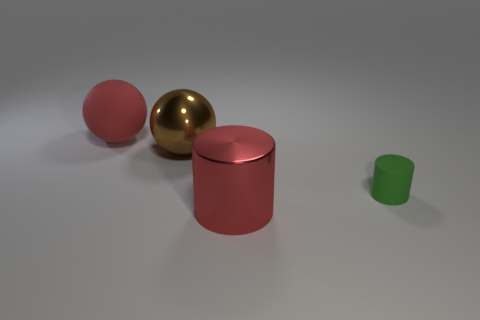Are there any other things that have the same size as the green matte cylinder?
Make the answer very short. No. Is the cylinder that is to the right of the large red metal thing made of the same material as the big red object that is behind the brown metal sphere?
Provide a short and direct response. Yes. Is the number of rubber cylinders behind the red ball greater than the number of metallic balls?
Give a very brief answer. No. What color is the matte thing that is behind the rubber thing that is right of the large red rubber object?
Make the answer very short. Red. There is a red metal object that is the same size as the red matte sphere; what is its shape?
Keep it short and to the point. Cylinder. What shape is the thing that is the same color as the shiny cylinder?
Offer a very short reply. Sphere. Are there an equal number of big brown metal objects that are on the right side of the small green rubber cylinder and large metallic cylinders?
Provide a succinct answer. No. There is a small green cylinder behind the metallic thing that is right of the big shiny thing behind the shiny cylinder; what is it made of?
Your response must be concise. Rubber. What is the shape of the small green object that is made of the same material as the red ball?
Give a very brief answer. Cylinder. Is there anything else that is the same color as the metal cylinder?
Provide a succinct answer. Yes. 